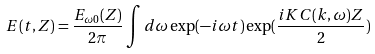Convert formula to latex. <formula><loc_0><loc_0><loc_500><loc_500>E ( t , Z ) = \frac { E _ { \omega 0 } ( Z ) } { 2 \pi } \int d \omega \exp ( - i \omega t ) \exp ( \frac { i K C ( k , \omega ) Z } { 2 } )</formula> 